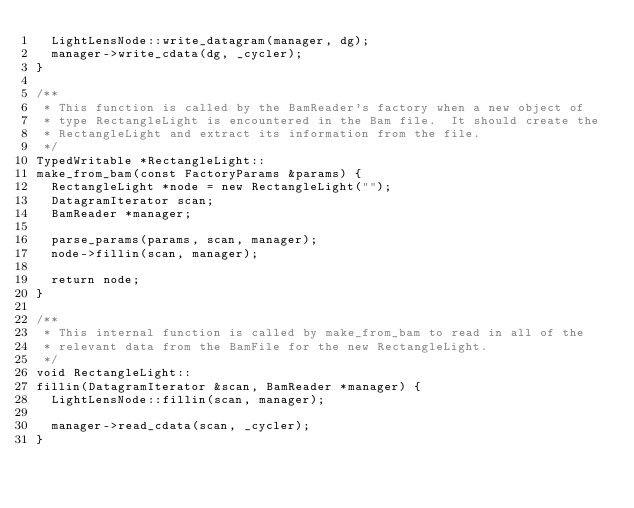<code> <loc_0><loc_0><loc_500><loc_500><_C++_>  LightLensNode::write_datagram(manager, dg);
  manager->write_cdata(dg, _cycler);
}

/**
 * This function is called by the BamReader's factory when a new object of
 * type RectangleLight is encountered in the Bam file.  It should create the
 * RectangleLight and extract its information from the file.
 */
TypedWritable *RectangleLight::
make_from_bam(const FactoryParams &params) {
  RectangleLight *node = new RectangleLight("");
  DatagramIterator scan;
  BamReader *manager;

  parse_params(params, scan, manager);
  node->fillin(scan, manager);

  return node;
}

/**
 * This internal function is called by make_from_bam to read in all of the
 * relevant data from the BamFile for the new RectangleLight.
 */
void RectangleLight::
fillin(DatagramIterator &scan, BamReader *manager) {
  LightLensNode::fillin(scan, manager);

  manager->read_cdata(scan, _cycler);
}
</code> 